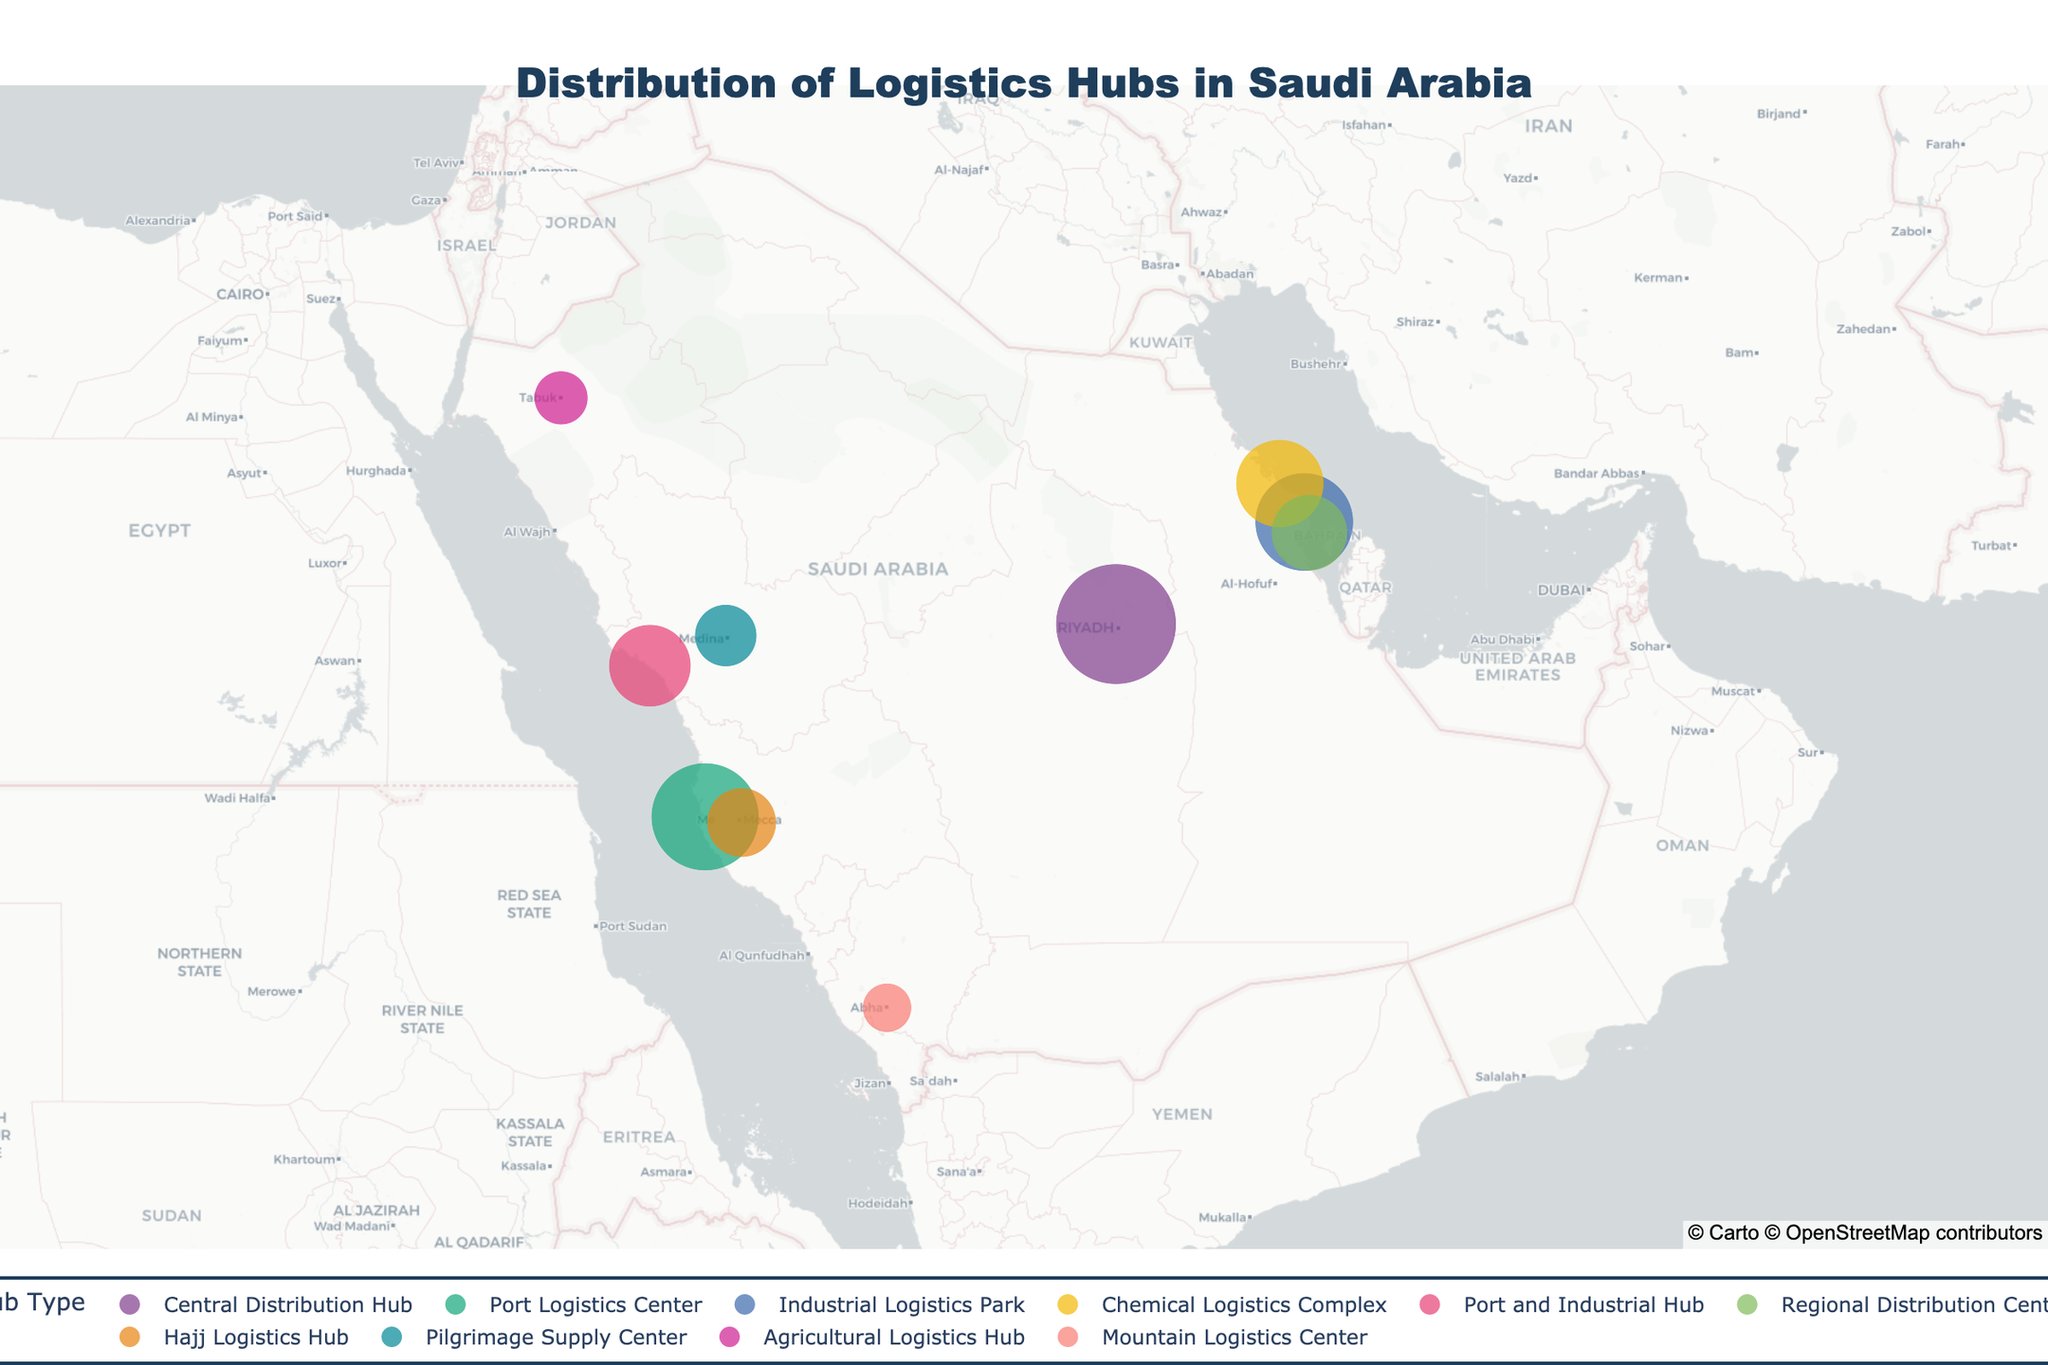What is the title of the figure? The title is usually found at the top of the figure and provides a summary of what the figure represents. Here, it is clearly labeled.
Answer: Distribution of Logistics Hubs in Saudi Arabia Which city hosts the largest logistics hub by capacity? To determine the largest logistics hub by capacity, look at the city with the largest circle.
Answer: Riyadh How many different types of logistics hubs are shown in the figure? Examine the legend to identify the number of unique hub types listed.
Answer: 9 Which city has a logistics hub that primarily caters to Religious Tourism? Hover over the cities to identify the major industries linked to Religious Tourism.
Answer: Mecca Comparing Riyadh and Jeddah, which city has a larger logistics hub capacity? Compare the circle sizes for Riyadh and Jeddah. Riyadh's circle is larger.
Answer: Riyadh What is the combined capacity of the logistics hubs in Dammam and Yanbu? Add the capacities of Dammam's and Yanbu's logistics hubs (100,000 sqm + 70,000 sqm).
Answer: 170,000 sqm Which two cities are closest to each other geographically? Observe the map for the nearest neighboring cities.
Answer: Dammam and Al-Khobar Which city hosts a logistics hub that serves Agribusiness among its major industries? Hover over the cities to find the hub serving Agribusiness.
Answer: Tabuk How does the capacity of the Chemical Logistics Complex in Jubail compare to the Mountain Logistics Center in Abha? Find the capacities of the logistics hubs in Jubail (80,000 sqm) and Abha (25,000 sqm) to compare them.
Answer: Jubail's is larger What is the average capacity of the logistics hubs in the cities along the western coast of Saudi Arabia (Jeddah, Yanbu, and Mecca)? Add the capacities of Jeddah, Yanbu, and Mecca (120,000 sqm + 70,000 sqm + 50,000 sqm) and divide by 3.
Answer: 80,000 sqm 